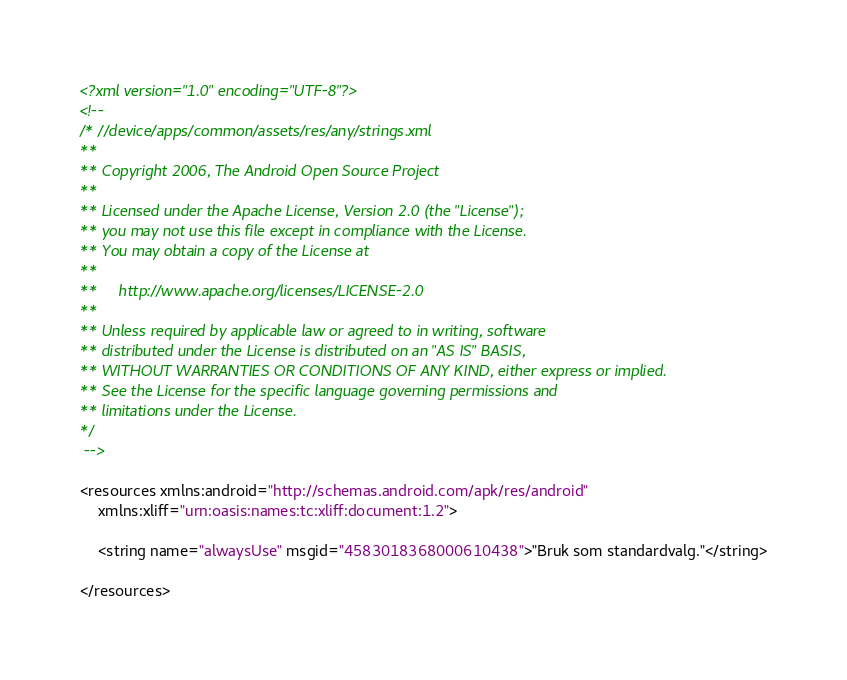Convert code to text. <code><loc_0><loc_0><loc_500><loc_500><_XML_><?xml version="1.0" encoding="UTF-8"?>
<!-- 
/* //device/apps/common/assets/res/any/strings.xml
**
** Copyright 2006, The Android Open Source Project
**
** Licensed under the Apache License, Version 2.0 (the "License");
** you may not use this file except in compliance with the License.
** You may obtain a copy of the License at
**
**     http://www.apache.org/licenses/LICENSE-2.0
**
** Unless required by applicable law or agreed to in writing, software
** distributed under the License is distributed on an "AS IS" BASIS,
** WITHOUT WARRANTIES OR CONDITIONS OF ANY KIND, either express or implied.
** See the License for the specific language governing permissions and
** limitations under the License.
*/
 -->

<resources xmlns:android="http://schemas.android.com/apk/res/android"
    xmlns:xliff="urn:oasis:names:tc:xliff:document:1.2">

    <string name="alwaysUse" msgid="4583018368000610438">"Bruk som standardvalg."</string>

</resources>
</code> 